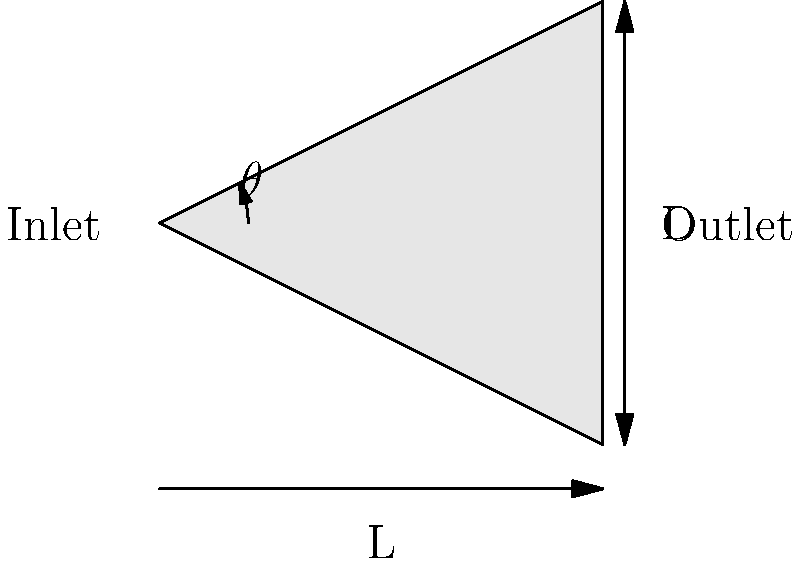A conical nozzle is designed for optimal fluid flow in a thermal system. The nozzle has a length (L) of 50 cm and an outlet diameter (D) of 20 cm. Calculate the optimal angle ($\theta$) of the nozzle for maximum fluid flow efficiency, given that the optimal angle is determined by the equation: $\tan(\frac{\theta}{2}) = \frac{D}{2L}$. To solve this problem, we'll follow these steps:

1) We are given:
   - Length (L) = 50 cm
   - Outlet diameter (D) = 20 cm
   - Equation: $\tan(\frac{\theta}{2}) = \frac{D}{2L}$

2) Substitute the known values into the equation:
   $\tan(\frac{\theta}{2}) = \frac{20}{2(50)} = \frac{20}{100} = 0.2$

3) To find $\theta$, we need to solve:
   $\frac{\theta}{2} = \arctan(0.2)$

4) Multiply both sides by 2:
   $\theta = 2 \arctan(0.2)$

5) Calculate the result:
   $\theta = 2 \cdot 11.31° = 22.62°$

6) Round to two decimal places:
   $\theta \approx 22.62°$

This angle represents the optimal cone angle for maximum fluid flow efficiency in the given nozzle configuration.
Answer: $22.62°$ 